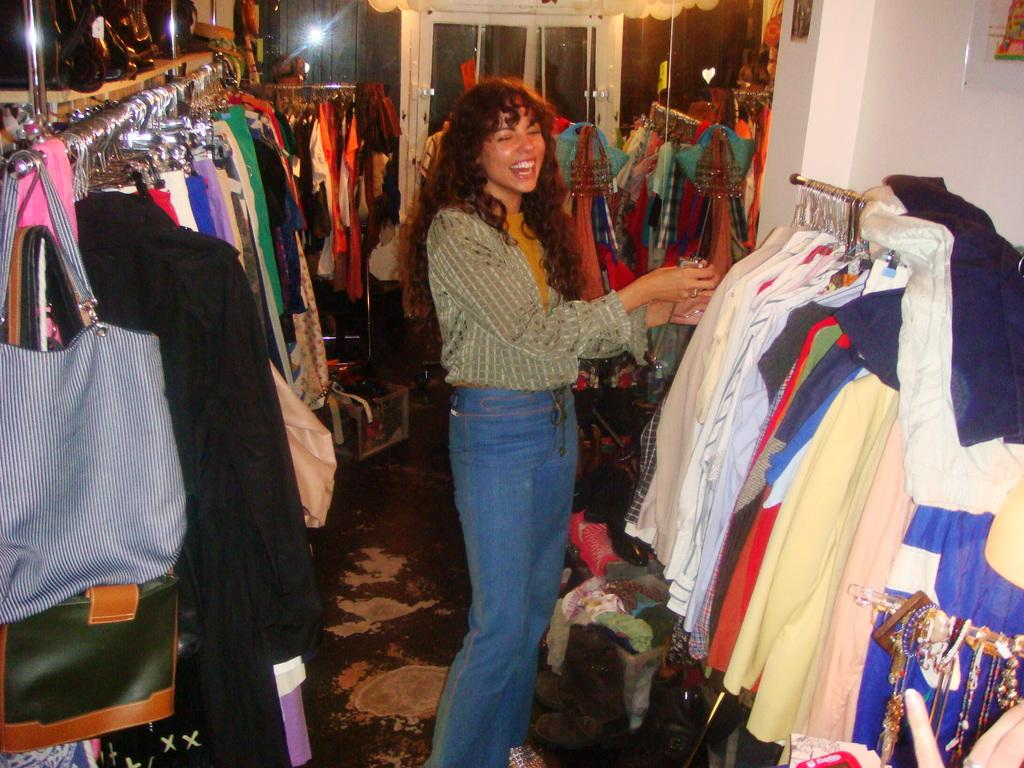What items are hanging in the image? There are clothes on hangers and bags on hangers in the image. Can you describe the person in the image? There is a person standing in the middle of the image, and they are wearing clothes. Is there any blood visible on the person's clothes in the image? No, there is no blood visible on the person's clothes in the image. How many people are present in the image? There is only one person present in the image. 